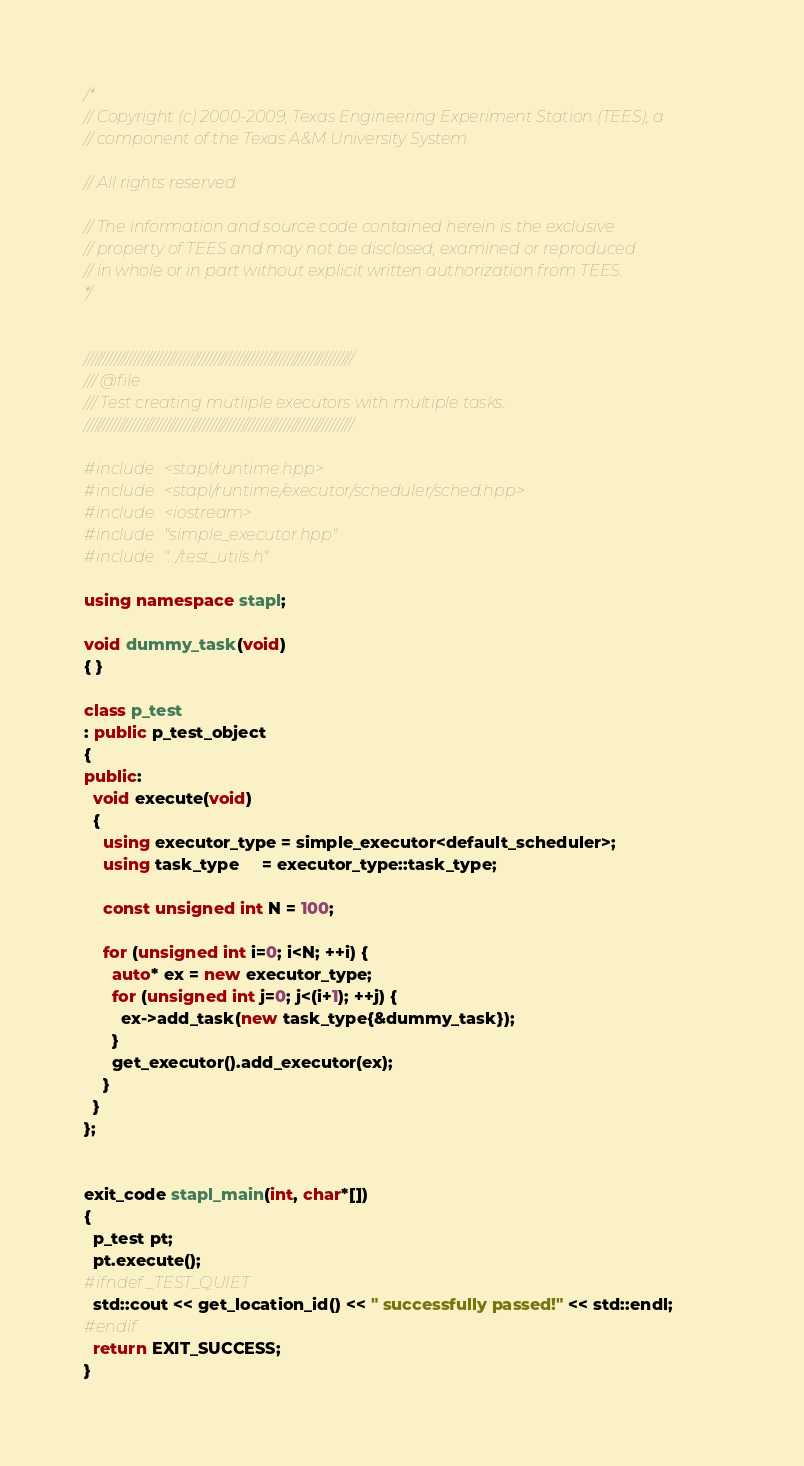Convert code to text. <code><loc_0><loc_0><loc_500><loc_500><_C++_>/*
// Copyright (c) 2000-2009, Texas Engineering Experiment Station (TEES), a
// component of the Texas A&M University System.

// All rights reserved.

// The information and source code contained herein is the exclusive
// property of TEES and may not be disclosed, examined or reproduced
// in whole or in part without explicit written authorization from TEES.
*/


//////////////////////////////////////////////////////////////////////
/// @file
/// Test creating mutliple executors with multiple tasks.
//////////////////////////////////////////////////////////////////////

#include <stapl/runtime.hpp>
#include <stapl/runtime/executor/scheduler/sched.hpp>
#include <iostream>
#include "simple_executor.hpp"
#include "../test_utils.h"

using namespace stapl;

void dummy_task(void)
{ }

class p_test
: public p_test_object
{
public:
  void execute(void)
  {
    using executor_type = simple_executor<default_scheduler>;
    using task_type     = executor_type::task_type;

    const unsigned int N = 100;

    for (unsigned int i=0; i<N; ++i) {
      auto* ex = new executor_type;
      for (unsigned int j=0; j<(i+1); ++j) {
        ex->add_task(new task_type{&dummy_task});
      }
      get_executor().add_executor(ex);
    }
  }
};


exit_code stapl_main(int, char*[])
{
  p_test pt;
  pt.execute();
#ifndef _TEST_QUIET
  std::cout << get_location_id() << " successfully passed!" << std::endl;
#endif
  return EXIT_SUCCESS;
}
</code> 